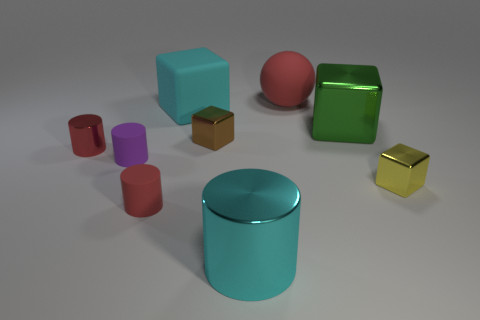How many large rubber objects have the same color as the matte cube?
Offer a terse response. 0. How many things are either things on the right side of the rubber cube or big rubber things that are on the right side of the cyan metallic cylinder?
Your response must be concise. 5. Is the number of red rubber spheres that are in front of the red matte cylinder less than the number of blue rubber blocks?
Offer a terse response. No. Is there a red thing that has the same size as the purple thing?
Keep it short and to the point. Yes. The large cylinder has what color?
Make the answer very short. Cyan. Does the red matte cylinder have the same size as the cyan metal cylinder?
Offer a terse response. No. What number of things are either small rubber cylinders or green shiny things?
Provide a short and direct response. 3. Is the number of cyan things that are to the left of the brown block the same as the number of tiny purple rubber things?
Keep it short and to the point. Yes. There is a big ball that is right of the large cyan object that is behind the tiny brown shiny object; is there a brown thing in front of it?
Offer a very short reply. Yes. What is the color of the tiny cylinder that is the same material as the tiny brown cube?
Make the answer very short. Red. 